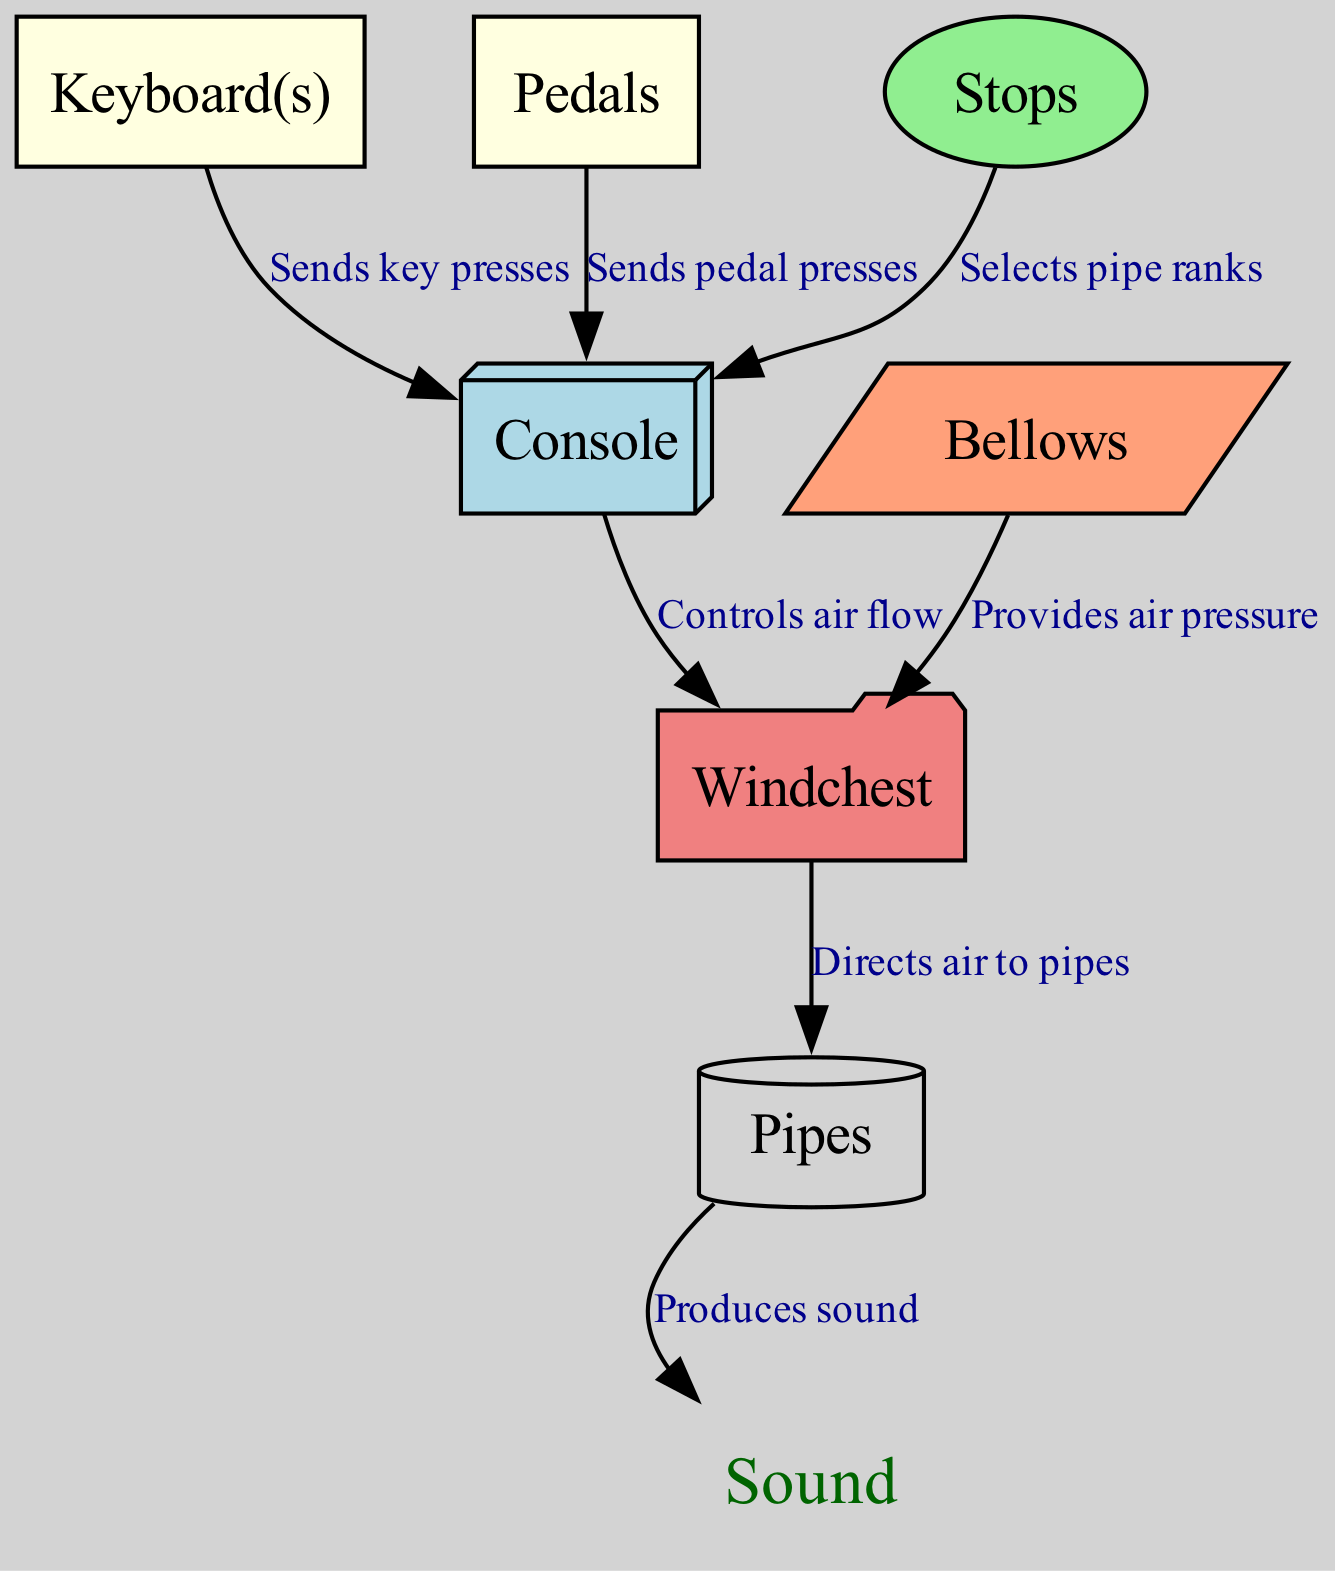What are the components of a church organ depicted in the diagram? The diagram lists the components of a church organ, which include Keyboard(s), Pedals, Console, Stops, Windchest, Pipes, and Bellows.
Answer: Keyboard(s), Pedals, Console, Stops, Windchest, Pipes, Bellows How many nodes are in the diagram? The diagram contains 7 nodes representing different components of the church organ. These nodes include Keyboard(s), Pedals, Console, Stops, Windchest, Pipes, and Bellows.
Answer: 7 Which component directs air to the pipes? The Windchest is indicated in the diagram as the component that directs air to the Pipes, as shown by the edge connecting these two nodes.
Answer: Windchest What does the Console control? The Console controls air flow to the Windchest, which is explicitly stated by the edge labeled "Controls air flow" from the Console to the Windchest in the diagram.
Answer: Air flow What is the function of the Bellows? The Bellows provides air pressure to the Windchest, as shown by the edge labeled "Provides air pressure" connecting the Bellows to the Windchest.
Answer: Provides air pressure How do the Stops interact with the Console? The Stops select pipe ranks, and this interaction is represented by the edge from Stops to Console labeled "Selects pipe ranks," indicating that Stops influence the function of the Console.
Answer: Selects pipe ranks What is the final output of the church organ system? The final output of the system is sound produced by the Pipes, as seen in the final edge connecting Pipes to a node labeled "Sound."
Answer: Sound Which two components send input to the Console? The Keyboard(s) and Pedals both send inputs to the Console, as they have individual edges connecting them to the Console, labeled "Sends key presses" and "Sends pedal presses", respectively.
Answer: Keyboard(s), Pedals What shapes represent the different components in the diagram? The shapes representing the components are diverse: Keyboard(s) and Pedals are rectangles, Console is a box3d, Stops are ellipses, Windchest is a folder, Pipes are cylinders, and Bellows are parallelograms.
Answer: Various shapes 